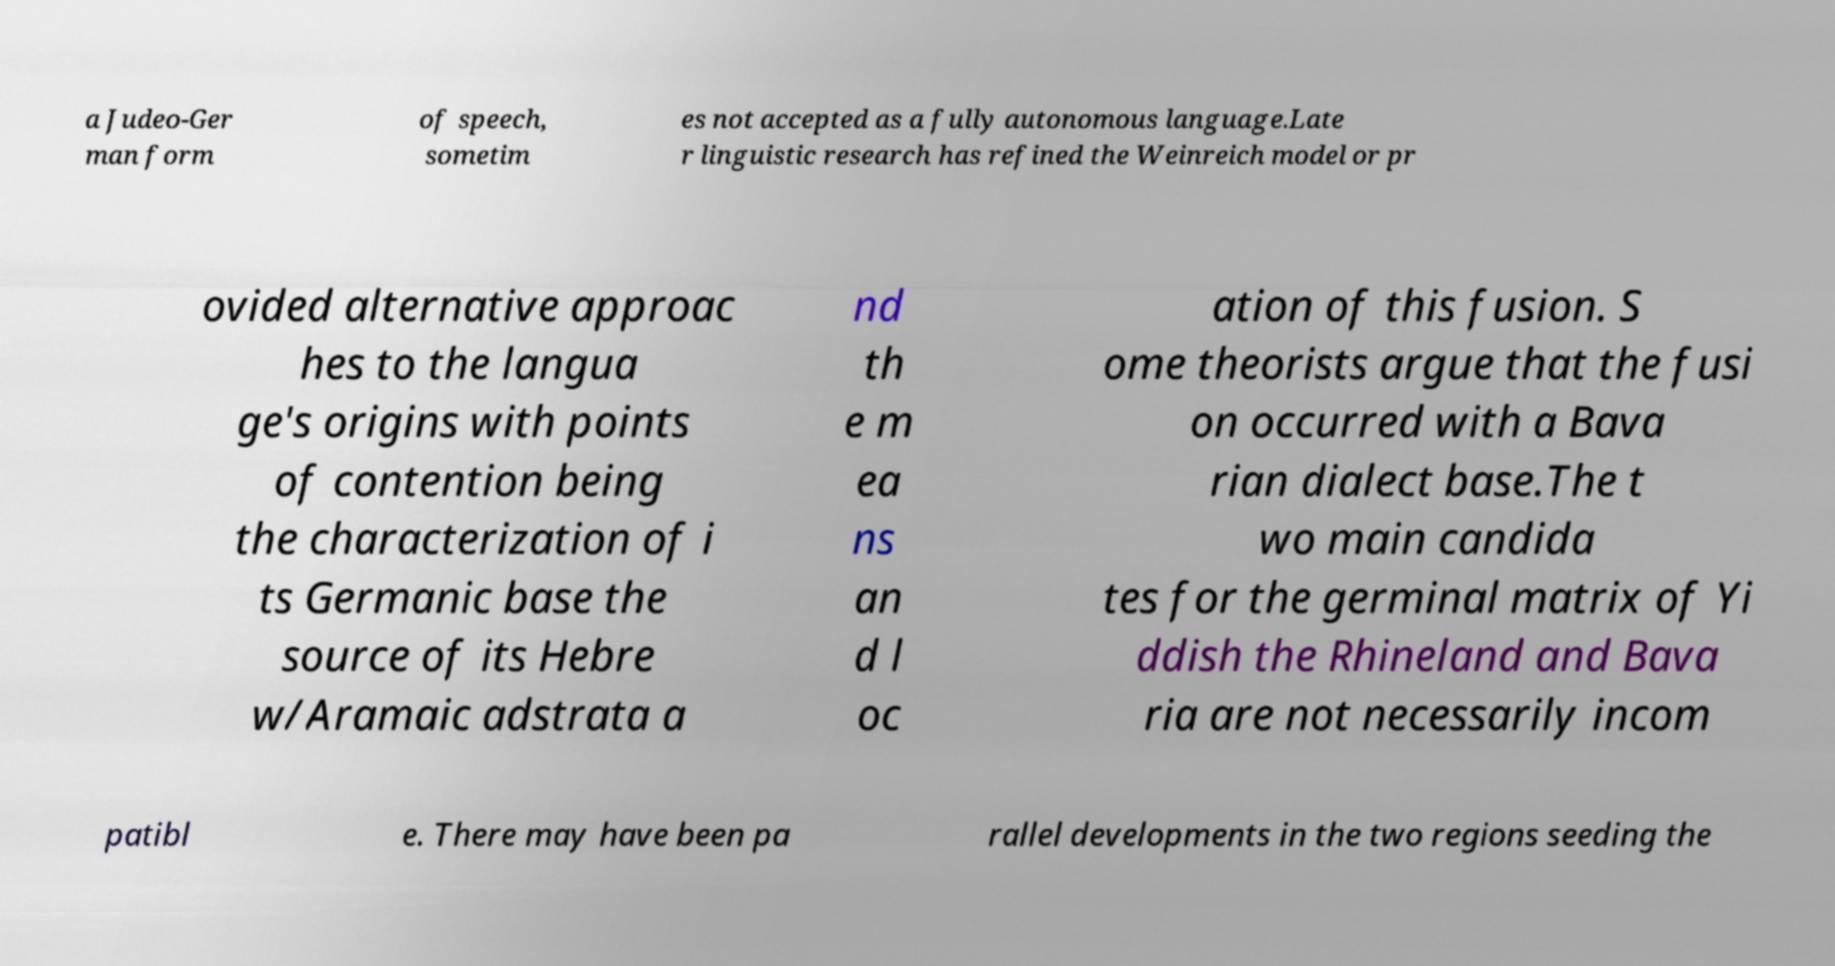Please identify and transcribe the text found in this image. a Judeo-Ger man form of speech, sometim es not accepted as a fully autonomous language.Late r linguistic research has refined the Weinreich model or pr ovided alternative approac hes to the langua ge's origins with points of contention being the characterization of i ts Germanic base the source of its Hebre w/Aramaic adstrata a nd th e m ea ns an d l oc ation of this fusion. S ome theorists argue that the fusi on occurred with a Bava rian dialect base.The t wo main candida tes for the germinal matrix of Yi ddish the Rhineland and Bava ria are not necessarily incom patibl e. There may have been pa rallel developments in the two regions seeding the 